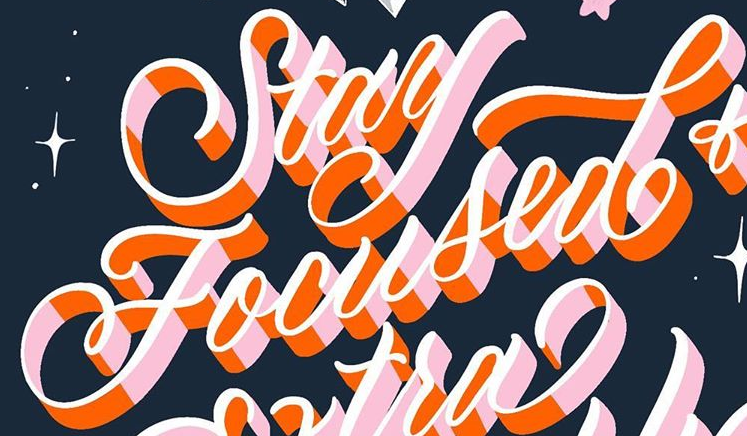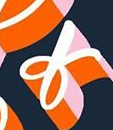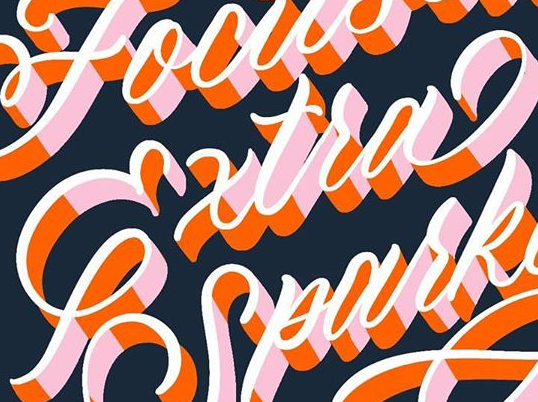Read the text from these images in sequence, separated by a semicolon. Focused; of; Extra 